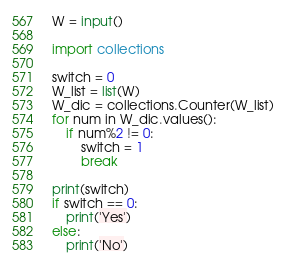<code> <loc_0><loc_0><loc_500><loc_500><_Python_>W = input()

import collections

switch = 0
W_list = list(W)
W_dic = collections.Counter(W_list)
for num in W_dic.values():
    if num%2 != 0:
        switch = 1
        break

print(switch)
if switch == 0:
    print('Yes')
else:
    print('No')</code> 